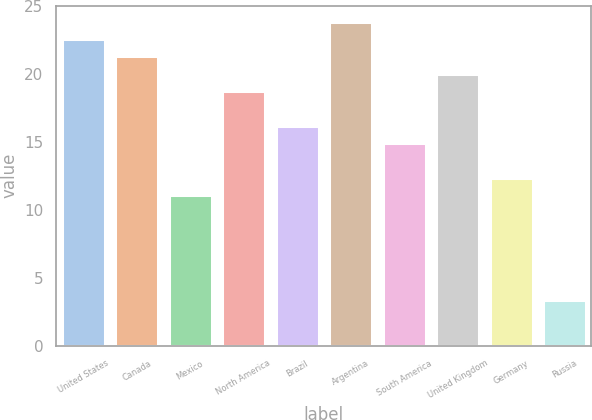Convert chart to OTSL. <chart><loc_0><loc_0><loc_500><loc_500><bar_chart><fcel>United States<fcel>Canada<fcel>Mexico<fcel>North America<fcel>Brazil<fcel>Argentina<fcel>South America<fcel>United Kingdom<fcel>Germany<fcel>Russia<nl><fcel>22.58<fcel>21.3<fcel>11.06<fcel>18.74<fcel>16.18<fcel>23.86<fcel>14.9<fcel>20.02<fcel>12.34<fcel>3.38<nl></chart> 